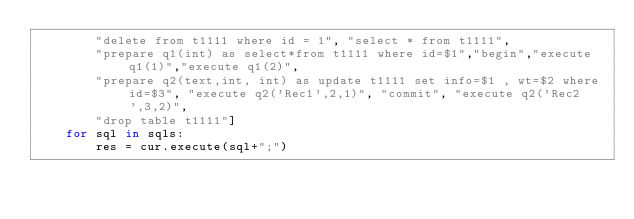Convert code to text. <code><loc_0><loc_0><loc_500><loc_500><_Python_>	    "delete from t1111 where id = 1", "select * from t1111",
		"prepare q1(int) as select*from t1111 where id=$1","begin","execute q1(1)","execute q1(2)",
		"prepare q2(text,int, int) as update t1111 set info=$1 , wt=$2 where id=$3", "execute q2('Rec1',2,1)", "commit", "execute q2('Rec2',3,2)",
	    "drop table t1111"]
	for sql in sqls:
	    res = cur.execute(sql+";")</code> 